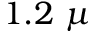<formula> <loc_0><loc_0><loc_500><loc_500>1 . 2 \mu</formula> 